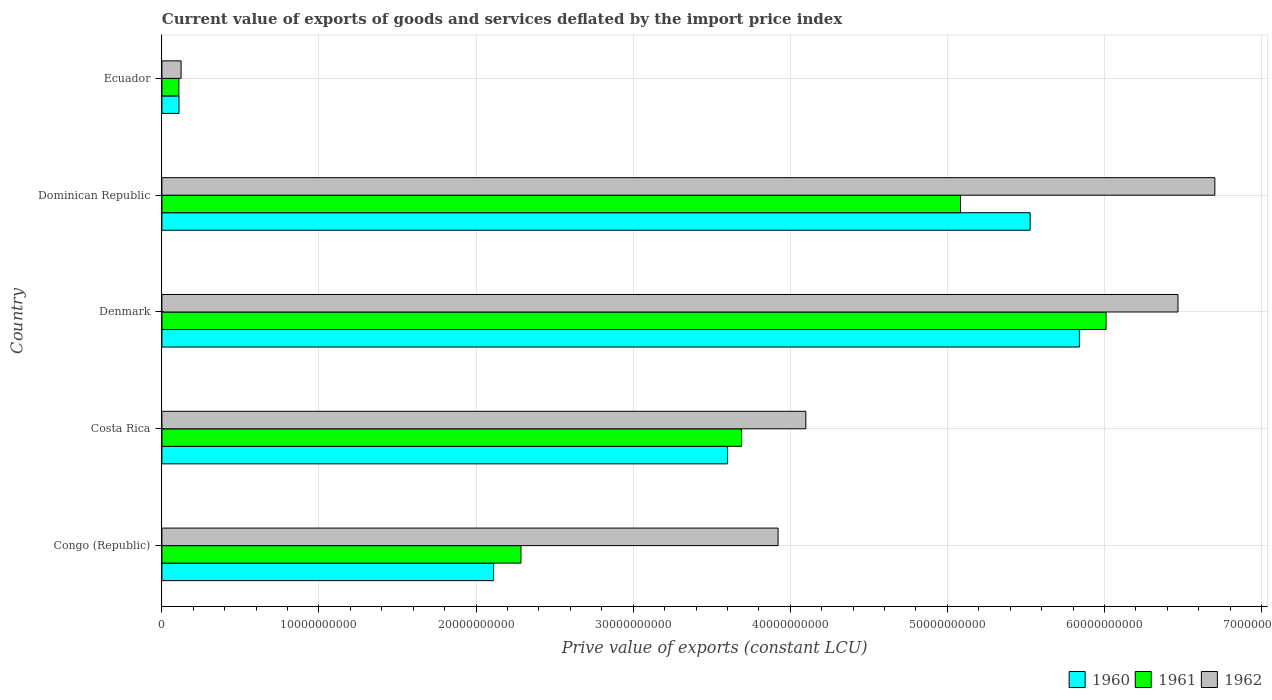How many groups of bars are there?
Offer a very short reply. 5. How many bars are there on the 5th tick from the bottom?
Offer a very short reply. 3. What is the label of the 4th group of bars from the top?
Give a very brief answer. Costa Rica. In how many cases, is the number of bars for a given country not equal to the number of legend labels?
Offer a terse response. 0. What is the prive value of exports in 1962 in Denmark?
Offer a terse response. 6.47e+1. Across all countries, what is the maximum prive value of exports in 1961?
Provide a short and direct response. 6.01e+1. Across all countries, what is the minimum prive value of exports in 1961?
Keep it short and to the point. 1.08e+09. In which country was the prive value of exports in 1962 maximum?
Your response must be concise. Dominican Republic. In which country was the prive value of exports in 1962 minimum?
Offer a very short reply. Ecuador. What is the total prive value of exports in 1961 in the graph?
Give a very brief answer. 1.72e+11. What is the difference between the prive value of exports in 1960 in Denmark and that in Dominican Republic?
Ensure brevity in your answer.  3.13e+09. What is the difference between the prive value of exports in 1961 in Ecuador and the prive value of exports in 1960 in Dominican Republic?
Your answer should be compact. -5.42e+1. What is the average prive value of exports in 1960 per country?
Offer a very short reply. 3.44e+1. What is the difference between the prive value of exports in 1960 and prive value of exports in 1962 in Ecuador?
Ensure brevity in your answer.  -1.34e+08. In how many countries, is the prive value of exports in 1962 greater than 16000000000 LCU?
Offer a terse response. 4. What is the ratio of the prive value of exports in 1960 in Congo (Republic) to that in Dominican Republic?
Your answer should be very brief. 0.38. Is the prive value of exports in 1961 in Costa Rica less than that in Ecuador?
Give a very brief answer. No. Is the difference between the prive value of exports in 1960 in Congo (Republic) and Ecuador greater than the difference between the prive value of exports in 1962 in Congo (Republic) and Ecuador?
Your answer should be compact. No. What is the difference between the highest and the second highest prive value of exports in 1960?
Ensure brevity in your answer.  3.13e+09. What is the difference between the highest and the lowest prive value of exports in 1962?
Provide a succinct answer. 6.58e+1. What does the 3rd bar from the top in Congo (Republic) represents?
Keep it short and to the point. 1960. What does the 3rd bar from the bottom in Denmark represents?
Give a very brief answer. 1962. Does the graph contain any zero values?
Offer a terse response. No. Does the graph contain grids?
Ensure brevity in your answer.  Yes. How are the legend labels stacked?
Provide a short and direct response. Horizontal. What is the title of the graph?
Provide a short and direct response. Current value of exports of goods and services deflated by the import price index. Does "1987" appear as one of the legend labels in the graph?
Offer a very short reply. No. What is the label or title of the X-axis?
Keep it short and to the point. Prive value of exports (constant LCU). What is the Prive value of exports (constant LCU) in 1960 in Congo (Republic)?
Offer a terse response. 2.11e+1. What is the Prive value of exports (constant LCU) in 1961 in Congo (Republic)?
Your response must be concise. 2.29e+1. What is the Prive value of exports (constant LCU) in 1962 in Congo (Republic)?
Give a very brief answer. 3.92e+1. What is the Prive value of exports (constant LCU) in 1960 in Costa Rica?
Keep it short and to the point. 3.60e+1. What is the Prive value of exports (constant LCU) of 1961 in Costa Rica?
Offer a terse response. 3.69e+1. What is the Prive value of exports (constant LCU) of 1962 in Costa Rica?
Provide a short and direct response. 4.10e+1. What is the Prive value of exports (constant LCU) of 1960 in Denmark?
Make the answer very short. 5.84e+1. What is the Prive value of exports (constant LCU) of 1961 in Denmark?
Offer a terse response. 6.01e+1. What is the Prive value of exports (constant LCU) in 1962 in Denmark?
Offer a terse response. 6.47e+1. What is the Prive value of exports (constant LCU) in 1960 in Dominican Republic?
Your answer should be compact. 5.53e+1. What is the Prive value of exports (constant LCU) of 1961 in Dominican Republic?
Make the answer very short. 5.08e+1. What is the Prive value of exports (constant LCU) of 1962 in Dominican Republic?
Your answer should be compact. 6.70e+1. What is the Prive value of exports (constant LCU) in 1960 in Ecuador?
Make the answer very short. 1.09e+09. What is the Prive value of exports (constant LCU) of 1961 in Ecuador?
Offer a terse response. 1.08e+09. What is the Prive value of exports (constant LCU) of 1962 in Ecuador?
Your response must be concise. 1.22e+09. Across all countries, what is the maximum Prive value of exports (constant LCU) in 1960?
Provide a succinct answer. 5.84e+1. Across all countries, what is the maximum Prive value of exports (constant LCU) in 1961?
Offer a very short reply. 6.01e+1. Across all countries, what is the maximum Prive value of exports (constant LCU) of 1962?
Your answer should be compact. 6.70e+1. Across all countries, what is the minimum Prive value of exports (constant LCU) in 1960?
Offer a very short reply. 1.09e+09. Across all countries, what is the minimum Prive value of exports (constant LCU) of 1961?
Your answer should be compact. 1.08e+09. Across all countries, what is the minimum Prive value of exports (constant LCU) in 1962?
Offer a very short reply. 1.22e+09. What is the total Prive value of exports (constant LCU) of 1960 in the graph?
Offer a very short reply. 1.72e+11. What is the total Prive value of exports (constant LCU) in 1961 in the graph?
Make the answer very short. 1.72e+11. What is the total Prive value of exports (constant LCU) in 1962 in the graph?
Offer a very short reply. 2.13e+11. What is the difference between the Prive value of exports (constant LCU) in 1960 in Congo (Republic) and that in Costa Rica?
Your response must be concise. -1.49e+1. What is the difference between the Prive value of exports (constant LCU) in 1961 in Congo (Republic) and that in Costa Rica?
Your response must be concise. -1.40e+1. What is the difference between the Prive value of exports (constant LCU) in 1962 in Congo (Republic) and that in Costa Rica?
Your answer should be very brief. -1.77e+09. What is the difference between the Prive value of exports (constant LCU) of 1960 in Congo (Republic) and that in Denmark?
Ensure brevity in your answer.  -3.73e+1. What is the difference between the Prive value of exports (constant LCU) in 1961 in Congo (Republic) and that in Denmark?
Ensure brevity in your answer.  -3.72e+1. What is the difference between the Prive value of exports (constant LCU) of 1962 in Congo (Republic) and that in Denmark?
Ensure brevity in your answer.  -2.55e+1. What is the difference between the Prive value of exports (constant LCU) in 1960 in Congo (Republic) and that in Dominican Republic?
Offer a very short reply. -3.42e+1. What is the difference between the Prive value of exports (constant LCU) of 1961 in Congo (Republic) and that in Dominican Republic?
Your answer should be compact. -2.80e+1. What is the difference between the Prive value of exports (constant LCU) of 1962 in Congo (Republic) and that in Dominican Republic?
Provide a succinct answer. -2.78e+1. What is the difference between the Prive value of exports (constant LCU) in 1960 in Congo (Republic) and that in Ecuador?
Your response must be concise. 2.00e+1. What is the difference between the Prive value of exports (constant LCU) in 1961 in Congo (Republic) and that in Ecuador?
Your answer should be compact. 2.18e+1. What is the difference between the Prive value of exports (constant LCU) in 1962 in Congo (Republic) and that in Ecuador?
Your answer should be compact. 3.80e+1. What is the difference between the Prive value of exports (constant LCU) of 1960 in Costa Rica and that in Denmark?
Make the answer very short. -2.24e+1. What is the difference between the Prive value of exports (constant LCU) in 1961 in Costa Rica and that in Denmark?
Your answer should be very brief. -2.32e+1. What is the difference between the Prive value of exports (constant LCU) in 1962 in Costa Rica and that in Denmark?
Offer a very short reply. -2.37e+1. What is the difference between the Prive value of exports (constant LCU) of 1960 in Costa Rica and that in Dominican Republic?
Make the answer very short. -1.93e+1. What is the difference between the Prive value of exports (constant LCU) of 1961 in Costa Rica and that in Dominican Republic?
Give a very brief answer. -1.39e+1. What is the difference between the Prive value of exports (constant LCU) in 1962 in Costa Rica and that in Dominican Republic?
Provide a succinct answer. -2.60e+1. What is the difference between the Prive value of exports (constant LCU) in 1960 in Costa Rica and that in Ecuador?
Provide a short and direct response. 3.49e+1. What is the difference between the Prive value of exports (constant LCU) of 1961 in Costa Rica and that in Ecuador?
Ensure brevity in your answer.  3.58e+1. What is the difference between the Prive value of exports (constant LCU) in 1962 in Costa Rica and that in Ecuador?
Provide a short and direct response. 3.98e+1. What is the difference between the Prive value of exports (constant LCU) in 1960 in Denmark and that in Dominican Republic?
Offer a terse response. 3.13e+09. What is the difference between the Prive value of exports (constant LCU) of 1961 in Denmark and that in Dominican Republic?
Ensure brevity in your answer.  9.26e+09. What is the difference between the Prive value of exports (constant LCU) in 1962 in Denmark and that in Dominican Republic?
Offer a terse response. -2.35e+09. What is the difference between the Prive value of exports (constant LCU) in 1960 in Denmark and that in Ecuador?
Your response must be concise. 5.73e+1. What is the difference between the Prive value of exports (constant LCU) in 1961 in Denmark and that in Ecuador?
Your response must be concise. 5.90e+1. What is the difference between the Prive value of exports (constant LCU) in 1962 in Denmark and that in Ecuador?
Provide a succinct answer. 6.35e+1. What is the difference between the Prive value of exports (constant LCU) in 1960 in Dominican Republic and that in Ecuador?
Offer a very short reply. 5.42e+1. What is the difference between the Prive value of exports (constant LCU) in 1961 in Dominican Republic and that in Ecuador?
Your response must be concise. 4.98e+1. What is the difference between the Prive value of exports (constant LCU) of 1962 in Dominican Republic and that in Ecuador?
Your response must be concise. 6.58e+1. What is the difference between the Prive value of exports (constant LCU) in 1960 in Congo (Republic) and the Prive value of exports (constant LCU) in 1961 in Costa Rica?
Provide a short and direct response. -1.58e+1. What is the difference between the Prive value of exports (constant LCU) in 1960 in Congo (Republic) and the Prive value of exports (constant LCU) in 1962 in Costa Rica?
Provide a succinct answer. -1.99e+1. What is the difference between the Prive value of exports (constant LCU) in 1961 in Congo (Republic) and the Prive value of exports (constant LCU) in 1962 in Costa Rica?
Provide a short and direct response. -1.81e+1. What is the difference between the Prive value of exports (constant LCU) of 1960 in Congo (Republic) and the Prive value of exports (constant LCU) of 1961 in Denmark?
Offer a terse response. -3.90e+1. What is the difference between the Prive value of exports (constant LCU) of 1960 in Congo (Republic) and the Prive value of exports (constant LCU) of 1962 in Denmark?
Ensure brevity in your answer.  -4.36e+1. What is the difference between the Prive value of exports (constant LCU) in 1961 in Congo (Republic) and the Prive value of exports (constant LCU) in 1962 in Denmark?
Give a very brief answer. -4.18e+1. What is the difference between the Prive value of exports (constant LCU) of 1960 in Congo (Republic) and the Prive value of exports (constant LCU) of 1961 in Dominican Republic?
Ensure brevity in your answer.  -2.97e+1. What is the difference between the Prive value of exports (constant LCU) of 1960 in Congo (Republic) and the Prive value of exports (constant LCU) of 1962 in Dominican Republic?
Provide a succinct answer. -4.59e+1. What is the difference between the Prive value of exports (constant LCU) of 1961 in Congo (Republic) and the Prive value of exports (constant LCU) of 1962 in Dominican Republic?
Your response must be concise. -4.42e+1. What is the difference between the Prive value of exports (constant LCU) of 1960 in Congo (Republic) and the Prive value of exports (constant LCU) of 1961 in Ecuador?
Provide a succinct answer. 2.00e+1. What is the difference between the Prive value of exports (constant LCU) of 1960 in Congo (Republic) and the Prive value of exports (constant LCU) of 1962 in Ecuador?
Your answer should be very brief. 1.99e+1. What is the difference between the Prive value of exports (constant LCU) in 1961 in Congo (Republic) and the Prive value of exports (constant LCU) in 1962 in Ecuador?
Give a very brief answer. 2.16e+1. What is the difference between the Prive value of exports (constant LCU) in 1960 in Costa Rica and the Prive value of exports (constant LCU) in 1961 in Denmark?
Your answer should be very brief. -2.41e+1. What is the difference between the Prive value of exports (constant LCU) of 1960 in Costa Rica and the Prive value of exports (constant LCU) of 1962 in Denmark?
Provide a short and direct response. -2.87e+1. What is the difference between the Prive value of exports (constant LCU) in 1961 in Costa Rica and the Prive value of exports (constant LCU) in 1962 in Denmark?
Provide a short and direct response. -2.78e+1. What is the difference between the Prive value of exports (constant LCU) of 1960 in Costa Rica and the Prive value of exports (constant LCU) of 1961 in Dominican Republic?
Make the answer very short. -1.48e+1. What is the difference between the Prive value of exports (constant LCU) in 1960 in Costa Rica and the Prive value of exports (constant LCU) in 1962 in Dominican Republic?
Give a very brief answer. -3.10e+1. What is the difference between the Prive value of exports (constant LCU) of 1961 in Costa Rica and the Prive value of exports (constant LCU) of 1962 in Dominican Republic?
Your answer should be compact. -3.01e+1. What is the difference between the Prive value of exports (constant LCU) in 1960 in Costa Rica and the Prive value of exports (constant LCU) in 1961 in Ecuador?
Provide a short and direct response. 3.49e+1. What is the difference between the Prive value of exports (constant LCU) of 1960 in Costa Rica and the Prive value of exports (constant LCU) of 1962 in Ecuador?
Offer a terse response. 3.48e+1. What is the difference between the Prive value of exports (constant LCU) in 1961 in Costa Rica and the Prive value of exports (constant LCU) in 1962 in Ecuador?
Your answer should be very brief. 3.57e+1. What is the difference between the Prive value of exports (constant LCU) in 1960 in Denmark and the Prive value of exports (constant LCU) in 1961 in Dominican Republic?
Give a very brief answer. 7.57e+09. What is the difference between the Prive value of exports (constant LCU) in 1960 in Denmark and the Prive value of exports (constant LCU) in 1962 in Dominican Republic?
Keep it short and to the point. -8.62e+09. What is the difference between the Prive value of exports (constant LCU) of 1961 in Denmark and the Prive value of exports (constant LCU) of 1962 in Dominican Republic?
Your answer should be very brief. -6.93e+09. What is the difference between the Prive value of exports (constant LCU) of 1960 in Denmark and the Prive value of exports (constant LCU) of 1961 in Ecuador?
Your answer should be very brief. 5.73e+1. What is the difference between the Prive value of exports (constant LCU) of 1960 in Denmark and the Prive value of exports (constant LCU) of 1962 in Ecuador?
Keep it short and to the point. 5.72e+1. What is the difference between the Prive value of exports (constant LCU) of 1961 in Denmark and the Prive value of exports (constant LCU) of 1962 in Ecuador?
Make the answer very short. 5.89e+1. What is the difference between the Prive value of exports (constant LCU) of 1960 in Dominican Republic and the Prive value of exports (constant LCU) of 1961 in Ecuador?
Keep it short and to the point. 5.42e+1. What is the difference between the Prive value of exports (constant LCU) of 1960 in Dominican Republic and the Prive value of exports (constant LCU) of 1962 in Ecuador?
Make the answer very short. 5.40e+1. What is the difference between the Prive value of exports (constant LCU) of 1961 in Dominican Republic and the Prive value of exports (constant LCU) of 1962 in Ecuador?
Offer a terse response. 4.96e+1. What is the average Prive value of exports (constant LCU) in 1960 per country?
Offer a very short reply. 3.44e+1. What is the average Prive value of exports (constant LCU) of 1961 per country?
Offer a very short reply. 3.44e+1. What is the average Prive value of exports (constant LCU) of 1962 per country?
Your answer should be very brief. 4.26e+1. What is the difference between the Prive value of exports (constant LCU) in 1960 and Prive value of exports (constant LCU) in 1961 in Congo (Republic)?
Make the answer very short. -1.75e+09. What is the difference between the Prive value of exports (constant LCU) of 1960 and Prive value of exports (constant LCU) of 1962 in Congo (Republic)?
Make the answer very short. -1.81e+1. What is the difference between the Prive value of exports (constant LCU) of 1961 and Prive value of exports (constant LCU) of 1962 in Congo (Republic)?
Offer a very short reply. -1.64e+1. What is the difference between the Prive value of exports (constant LCU) in 1960 and Prive value of exports (constant LCU) in 1961 in Costa Rica?
Provide a succinct answer. -8.99e+08. What is the difference between the Prive value of exports (constant LCU) in 1960 and Prive value of exports (constant LCU) in 1962 in Costa Rica?
Keep it short and to the point. -4.99e+09. What is the difference between the Prive value of exports (constant LCU) in 1961 and Prive value of exports (constant LCU) in 1962 in Costa Rica?
Give a very brief answer. -4.09e+09. What is the difference between the Prive value of exports (constant LCU) in 1960 and Prive value of exports (constant LCU) in 1961 in Denmark?
Your answer should be very brief. -1.70e+09. What is the difference between the Prive value of exports (constant LCU) of 1960 and Prive value of exports (constant LCU) of 1962 in Denmark?
Your answer should be compact. -6.28e+09. What is the difference between the Prive value of exports (constant LCU) of 1961 and Prive value of exports (constant LCU) of 1962 in Denmark?
Give a very brief answer. -4.58e+09. What is the difference between the Prive value of exports (constant LCU) of 1960 and Prive value of exports (constant LCU) of 1961 in Dominican Republic?
Keep it short and to the point. 4.43e+09. What is the difference between the Prive value of exports (constant LCU) of 1960 and Prive value of exports (constant LCU) of 1962 in Dominican Republic?
Offer a terse response. -1.18e+1. What is the difference between the Prive value of exports (constant LCU) in 1961 and Prive value of exports (constant LCU) in 1962 in Dominican Republic?
Provide a short and direct response. -1.62e+1. What is the difference between the Prive value of exports (constant LCU) of 1960 and Prive value of exports (constant LCU) of 1961 in Ecuador?
Offer a very short reply. 7.73e+06. What is the difference between the Prive value of exports (constant LCU) in 1960 and Prive value of exports (constant LCU) in 1962 in Ecuador?
Provide a short and direct response. -1.34e+08. What is the difference between the Prive value of exports (constant LCU) in 1961 and Prive value of exports (constant LCU) in 1962 in Ecuador?
Offer a terse response. -1.41e+08. What is the ratio of the Prive value of exports (constant LCU) in 1960 in Congo (Republic) to that in Costa Rica?
Ensure brevity in your answer.  0.59. What is the ratio of the Prive value of exports (constant LCU) in 1961 in Congo (Republic) to that in Costa Rica?
Your answer should be very brief. 0.62. What is the ratio of the Prive value of exports (constant LCU) of 1962 in Congo (Republic) to that in Costa Rica?
Provide a short and direct response. 0.96. What is the ratio of the Prive value of exports (constant LCU) in 1960 in Congo (Republic) to that in Denmark?
Provide a succinct answer. 0.36. What is the ratio of the Prive value of exports (constant LCU) of 1961 in Congo (Republic) to that in Denmark?
Offer a very short reply. 0.38. What is the ratio of the Prive value of exports (constant LCU) of 1962 in Congo (Republic) to that in Denmark?
Keep it short and to the point. 0.61. What is the ratio of the Prive value of exports (constant LCU) in 1960 in Congo (Republic) to that in Dominican Republic?
Provide a short and direct response. 0.38. What is the ratio of the Prive value of exports (constant LCU) in 1961 in Congo (Republic) to that in Dominican Republic?
Ensure brevity in your answer.  0.45. What is the ratio of the Prive value of exports (constant LCU) in 1962 in Congo (Republic) to that in Dominican Republic?
Offer a terse response. 0.59. What is the ratio of the Prive value of exports (constant LCU) of 1960 in Congo (Republic) to that in Ecuador?
Make the answer very short. 19.4. What is the ratio of the Prive value of exports (constant LCU) in 1961 in Congo (Republic) to that in Ecuador?
Provide a succinct answer. 21.16. What is the ratio of the Prive value of exports (constant LCU) of 1962 in Congo (Republic) to that in Ecuador?
Provide a short and direct response. 32.11. What is the ratio of the Prive value of exports (constant LCU) of 1960 in Costa Rica to that in Denmark?
Offer a terse response. 0.62. What is the ratio of the Prive value of exports (constant LCU) in 1961 in Costa Rica to that in Denmark?
Make the answer very short. 0.61. What is the ratio of the Prive value of exports (constant LCU) in 1962 in Costa Rica to that in Denmark?
Keep it short and to the point. 0.63. What is the ratio of the Prive value of exports (constant LCU) of 1960 in Costa Rica to that in Dominican Republic?
Keep it short and to the point. 0.65. What is the ratio of the Prive value of exports (constant LCU) of 1961 in Costa Rica to that in Dominican Republic?
Make the answer very short. 0.73. What is the ratio of the Prive value of exports (constant LCU) in 1962 in Costa Rica to that in Dominican Republic?
Keep it short and to the point. 0.61. What is the ratio of the Prive value of exports (constant LCU) of 1960 in Costa Rica to that in Ecuador?
Ensure brevity in your answer.  33.09. What is the ratio of the Prive value of exports (constant LCU) in 1961 in Costa Rica to that in Ecuador?
Your answer should be very brief. 34.15. What is the ratio of the Prive value of exports (constant LCU) in 1962 in Costa Rica to that in Ecuador?
Provide a short and direct response. 33.55. What is the ratio of the Prive value of exports (constant LCU) in 1960 in Denmark to that in Dominican Republic?
Give a very brief answer. 1.06. What is the ratio of the Prive value of exports (constant LCU) of 1961 in Denmark to that in Dominican Republic?
Provide a succinct answer. 1.18. What is the ratio of the Prive value of exports (constant LCU) in 1960 in Denmark to that in Ecuador?
Your answer should be compact. 53.67. What is the ratio of the Prive value of exports (constant LCU) in 1961 in Denmark to that in Ecuador?
Provide a short and direct response. 55.63. What is the ratio of the Prive value of exports (constant LCU) in 1962 in Denmark to that in Ecuador?
Offer a terse response. 52.94. What is the ratio of the Prive value of exports (constant LCU) in 1960 in Dominican Republic to that in Ecuador?
Your answer should be very brief. 50.79. What is the ratio of the Prive value of exports (constant LCU) in 1961 in Dominican Republic to that in Ecuador?
Provide a short and direct response. 47.06. What is the ratio of the Prive value of exports (constant LCU) of 1962 in Dominican Republic to that in Ecuador?
Provide a succinct answer. 54.86. What is the difference between the highest and the second highest Prive value of exports (constant LCU) in 1960?
Make the answer very short. 3.13e+09. What is the difference between the highest and the second highest Prive value of exports (constant LCU) of 1961?
Your answer should be very brief. 9.26e+09. What is the difference between the highest and the second highest Prive value of exports (constant LCU) in 1962?
Offer a terse response. 2.35e+09. What is the difference between the highest and the lowest Prive value of exports (constant LCU) of 1960?
Your answer should be very brief. 5.73e+1. What is the difference between the highest and the lowest Prive value of exports (constant LCU) of 1961?
Make the answer very short. 5.90e+1. What is the difference between the highest and the lowest Prive value of exports (constant LCU) of 1962?
Keep it short and to the point. 6.58e+1. 